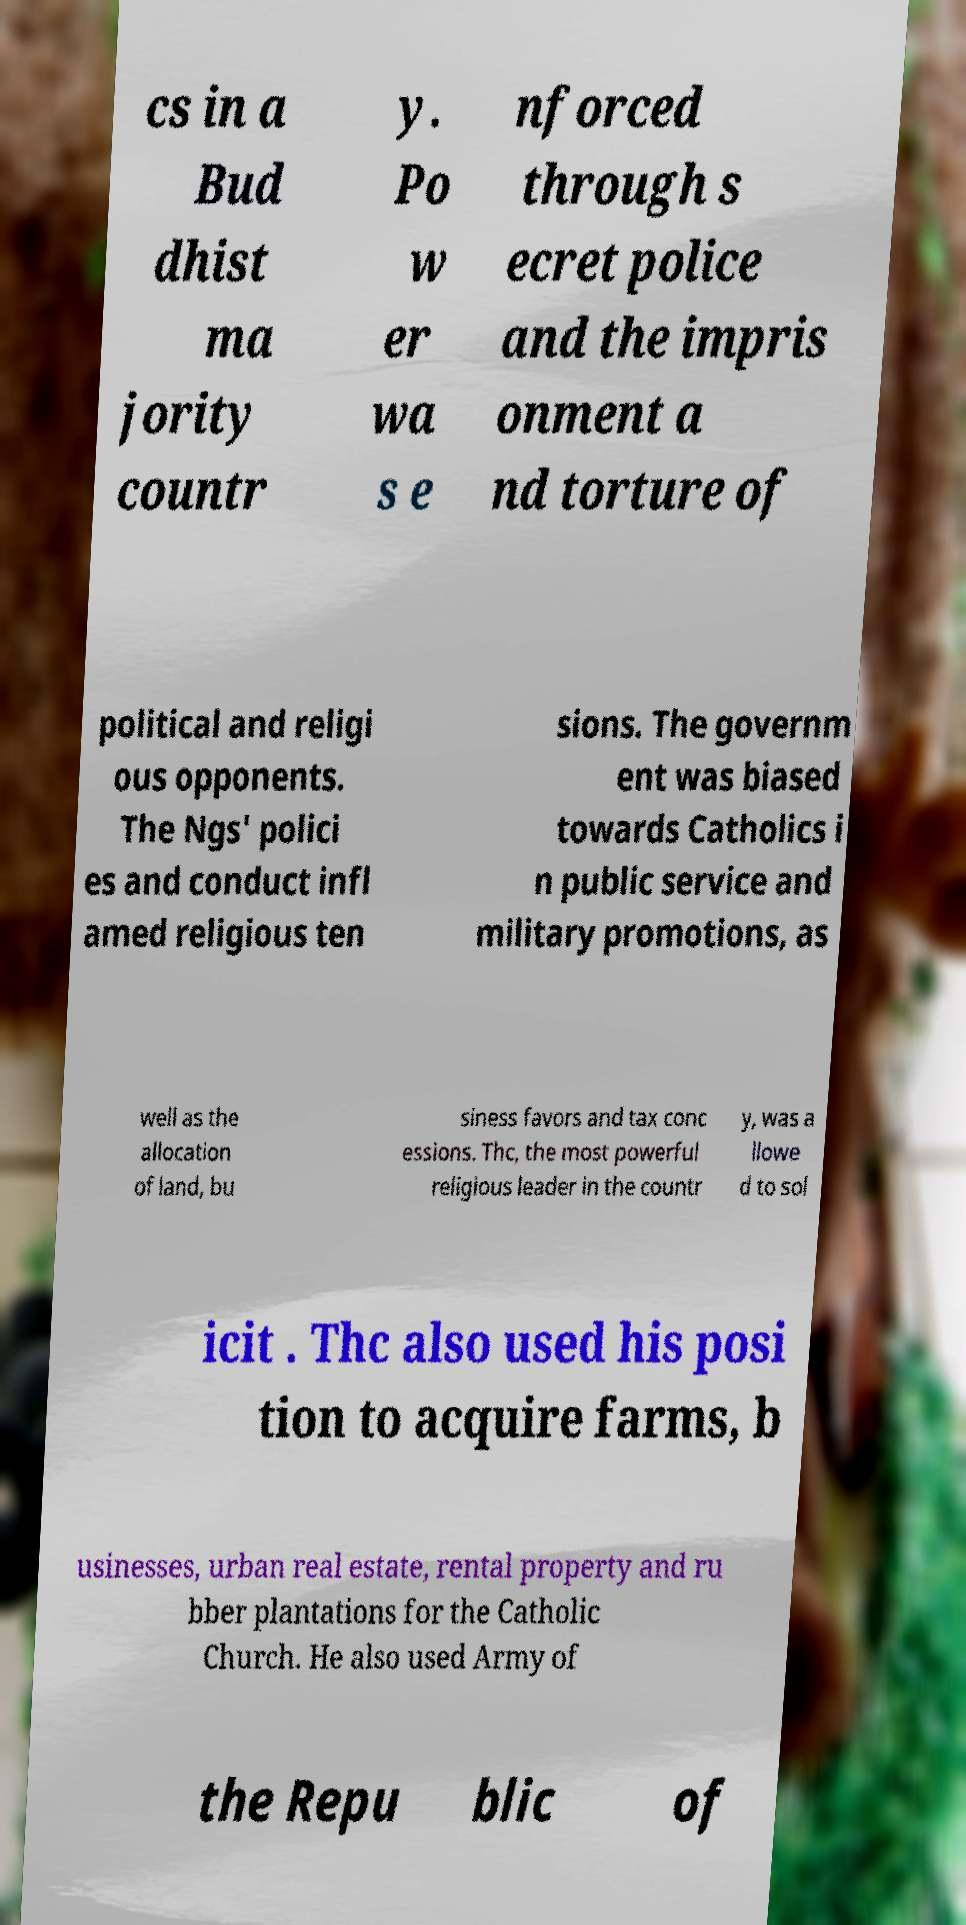For documentation purposes, I need the text within this image transcribed. Could you provide that? cs in a Bud dhist ma jority countr y. Po w er wa s e nforced through s ecret police and the impris onment a nd torture of political and religi ous opponents. The Ngs' polici es and conduct infl amed religious ten sions. The governm ent was biased towards Catholics i n public service and military promotions, as well as the allocation of land, bu siness favors and tax conc essions. Thc, the most powerful religious leader in the countr y, was a llowe d to sol icit . Thc also used his posi tion to acquire farms, b usinesses, urban real estate, rental property and ru bber plantations for the Catholic Church. He also used Army of the Repu blic of 